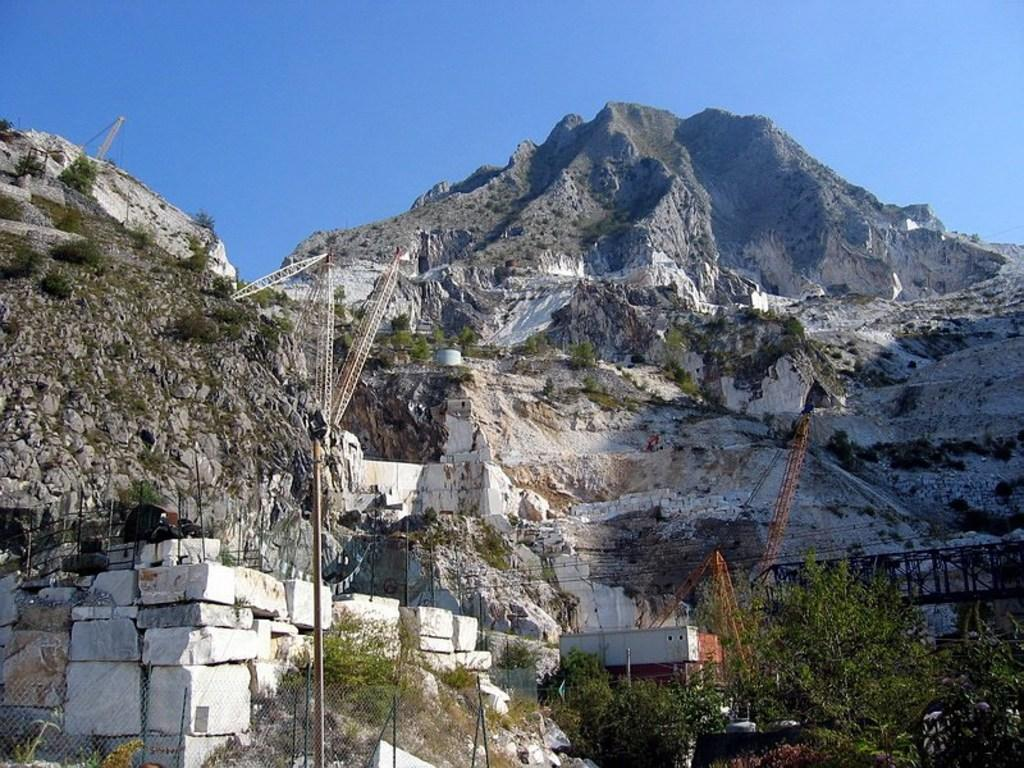What type of natural elements can be seen in the image? There are trees, rocks, and mountains in the image. What man-made structures are present in the image? There is a fence and poles in the image. What is visible in the background of the image? The sky is visible in the background of the image. Can you describe the unspecified objects in the image? Unfortunately, the facts provided do not specify the nature or appearance of these objects. What type of collar is the grandfather wearing in the image? There is no grandfather or collar present in the image. What type of home is depicted in the image? The facts provided do not mention a home or any residential structure in the image. 